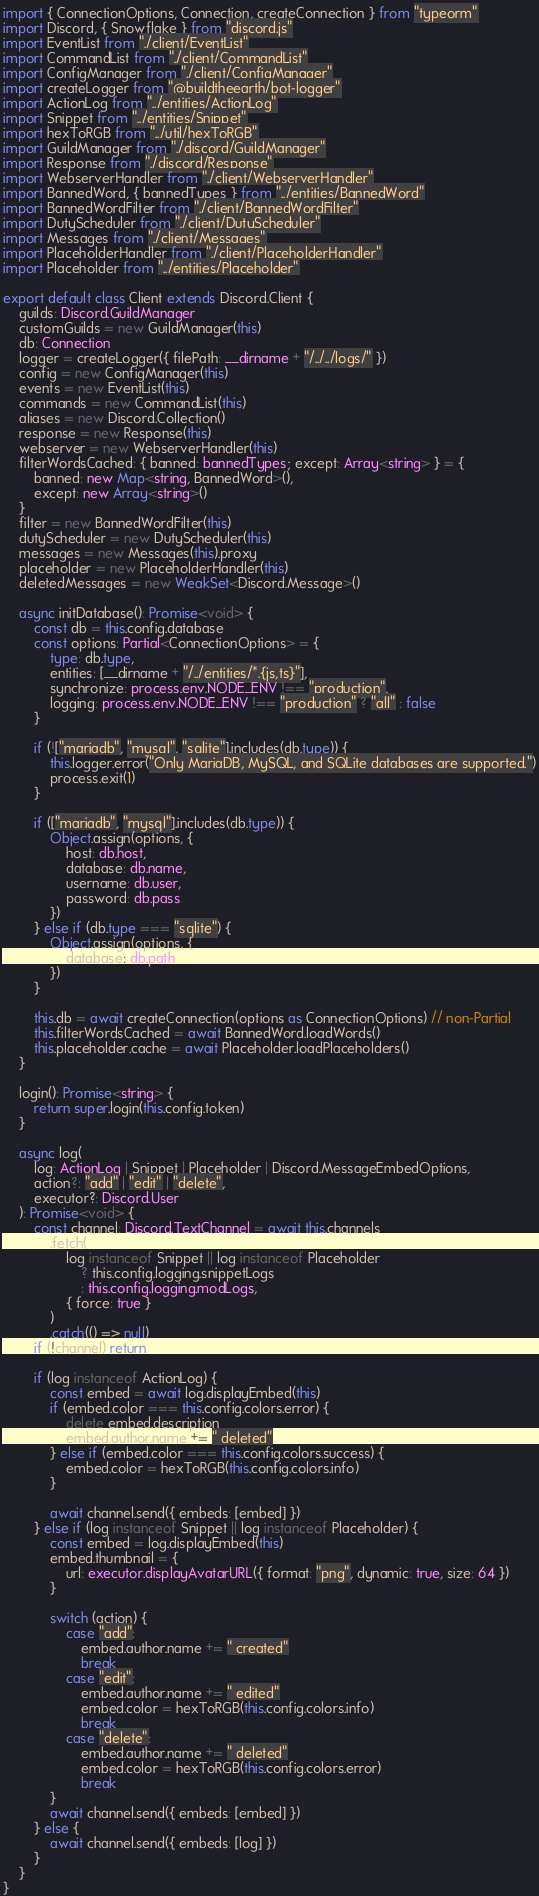<code> <loc_0><loc_0><loc_500><loc_500><_TypeScript_>import { ConnectionOptions, Connection, createConnection } from "typeorm"
import Discord, { Snowflake } from "discord.js"
import EventList from "./client/EventList"
import CommandList from "./client/CommandList"
import ConfigManager from "./client/ConfigManager"
import createLogger from "@buildtheearth/bot-logger"
import ActionLog from "../entities/ActionLog"
import Snippet from "../entities/Snippet"
import hexToRGB from "../util/hexToRGB"
import GuildManager from "./discord/GuildManager"
import Response from "./discord/Response"
import WebserverHandler from "./client/WebserverHandler"
import BannedWord, { bannedTypes } from "../entities/BannedWord"
import BannedWordFilter from "./client/BannedWordFilter"
import DutyScheduler from "./client/DutyScheduler"
import Messages from "./client/Messages"
import PlaceholderHandler from "./client/PlaceholderHandler"
import Placeholder from "../entities/Placeholder"

export default class Client extends Discord.Client {
    guilds: Discord.GuildManager
    customGuilds = new GuildManager(this)
    db: Connection
    logger = createLogger({ filePath: __dirname + "/../../logs/" })
    config = new ConfigManager(this)
    events = new EventList(this)
    commands = new CommandList(this)
    aliases = new Discord.Collection()
    response = new Response(this)
    webserver = new WebserverHandler(this)
    filterWordsCached: { banned: bannedTypes; except: Array<string> } = {
        banned: new Map<string, BannedWord>(),
        except: new Array<string>()
    }
    filter = new BannedWordFilter(this)
    dutyScheduler = new DutyScheduler(this)
    messages = new Messages(this).proxy
    placeholder = new PlaceholderHandler(this)
    deletedMessages = new WeakSet<Discord.Message>()

    async initDatabase(): Promise<void> {
        const db = this.config.database
        const options: Partial<ConnectionOptions> = {
            type: db.type,
            entities: [__dirname + "/../entities/*.{js,ts}"],
            synchronize: process.env.NODE_ENV !== "production",
            logging: process.env.NODE_ENV !== "production" ? "all" : false
        }

        if (!["mariadb", "mysql", "sqlite"].includes(db.type)) {
            this.logger.error("Only MariaDB, MySQL, and SQLite databases are supported.")
            process.exit(1)
        }

        if (["mariadb", "mysql"].includes(db.type)) {
            Object.assign(options, {
                host: db.host,
                database: db.name,
                username: db.user,
                password: db.pass
            })
        } else if (db.type === "sqlite") {
            Object.assign(options, {
                database: db.path
            })
        }

        this.db = await createConnection(options as ConnectionOptions) // non-Partial
        this.filterWordsCached = await BannedWord.loadWords()
        this.placeholder.cache = await Placeholder.loadPlaceholders()
    }

    login(): Promise<string> {
        return super.login(this.config.token)
    }

    async log(
        log: ActionLog | Snippet | Placeholder | Discord.MessageEmbedOptions,
        action?: "add" | "edit" | "delete",
        executor?: Discord.User
    ): Promise<void> {
        const channel: Discord.TextChannel = await this.channels
            .fetch(
                log instanceof Snippet || log instanceof Placeholder
                    ? this.config.logging.snippetLogs
                    : this.config.logging.modLogs,
                { force: true }
            )
            .catch(() => null)
        if (!channel) return

        if (log instanceof ActionLog) {
            const embed = await log.displayEmbed(this)
            if (embed.color === this.config.colors.error) {
                delete embed.description
                embed.author.name += " deleted"
            } else if (embed.color === this.config.colors.success) {
                embed.color = hexToRGB(this.config.colors.info)
            }

            await channel.send({ embeds: [embed] })
        } else if (log instanceof Snippet || log instanceof Placeholder) {
            const embed = log.displayEmbed(this)
            embed.thumbnail = {
                url: executor.displayAvatarURL({ format: "png", dynamic: true, size: 64 })
            }

            switch (action) {
                case "add":
                    embed.author.name += " created"
                    break
                case "edit":
                    embed.author.name += " edited"
                    embed.color = hexToRGB(this.config.colors.info)
                    break
                case "delete":
                    embed.author.name += " deleted"
                    embed.color = hexToRGB(this.config.colors.error)
                    break
            }
            await channel.send({ embeds: [embed] })
        } else {
            await channel.send({ embeds: [log] })
        }
    }
}
</code> 